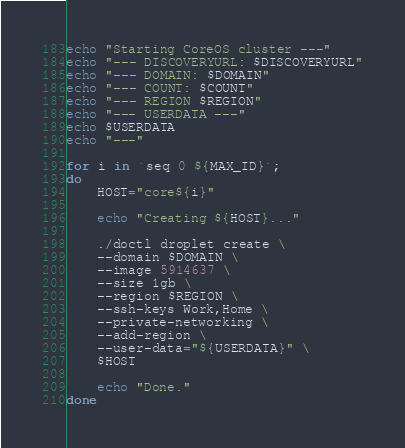Convert code to text. <code><loc_0><loc_0><loc_500><loc_500><_Bash_>echo "Starting CoreOS cluster ---"
echo "--- DISCOVERYURL: $DISCOVERYURL"
echo "--- DOMAIN: $DOMAIN"
echo "--- COUNT: $COUNT"
echo "--- REGION $REGION"
echo "--- USERDATA ---"
echo $USERDATA
echo "---"

for i in `seq 0 ${MAX_ID}`;
do
	HOST="core${i}"

	echo "Creating ${HOST}..."

	./doctl droplet create \
	--domain $DOMAIN \
	--image 5914637 \
	--size 1gb \
	--region $REGION \
	--ssh-keys Work,Home \
	--private-networking \
	--add-region \
	--user-data="${USERDATA}" \
	$HOST

    echo "Done."
done  </code> 